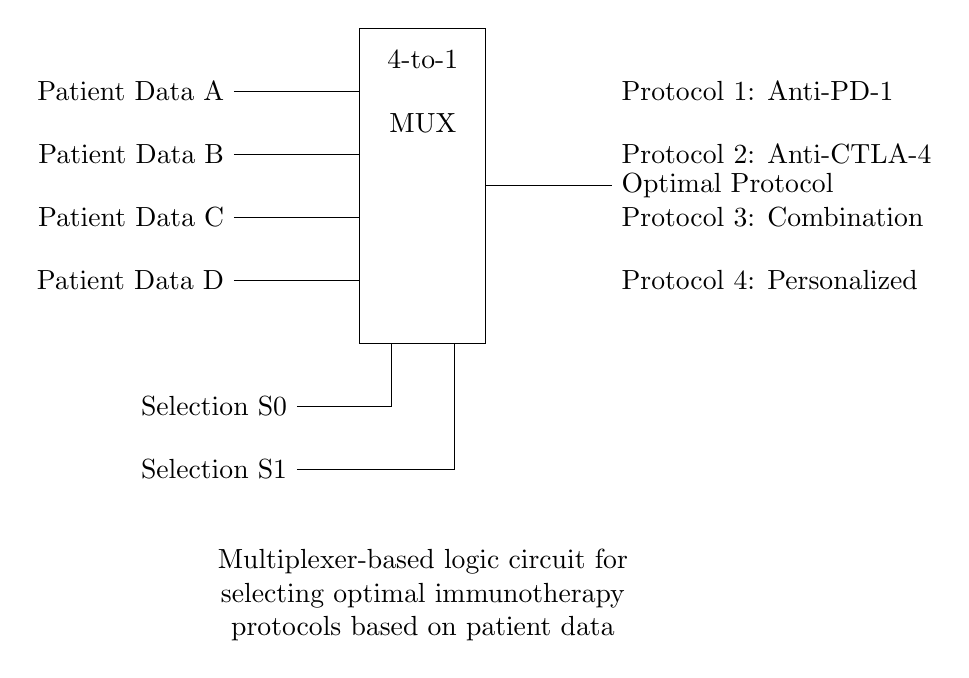What type of circuit is shown? The circuit represents a multiplexer, specifically a 4-to-1 multiplexer, which takes multiple inputs and selects one output based on selection lines.
Answer: Multiplexer How many input data lines are there? There are four input data lines labeled as Patient Data A, B, C, and D, as indicated in the diagram.
Answer: Four What are the selection lines in this circuit? The selection lines are labeled as S0 and S1, which are used to choose which input data line is output by the multiplexer.
Answer: S0 and S1 What is the output of the multiplexer? The output labeled as "Optimal Protocol" signifies the selected immunotherapy protocol based on the input data and selection lines.
Answer: Optimal Protocol What protocols can the output select? The protocols include Anti-PD-1, Anti-CTLA-4, Combination, and Personalized, which are presented on the right side of the output.
Answer: Anti-PD-1, Anti-CTLA-4, Combination, Personalized Explain how the selection lines determine the output. The selection lines S0 and S1 utilize binary encoding to select one of the four input lines. Depending on their binary combination (00, 01, 10, or 11), one of the inputs A, B, C, or D is routed to the output as the "Optimal Protocol".
Answer: Binary encoding 